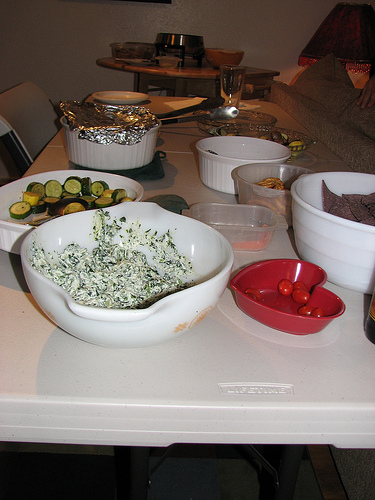<image>
Is there a candy above the table? Yes. The candy is positioned above the table in the vertical space, higher up in the scene. 